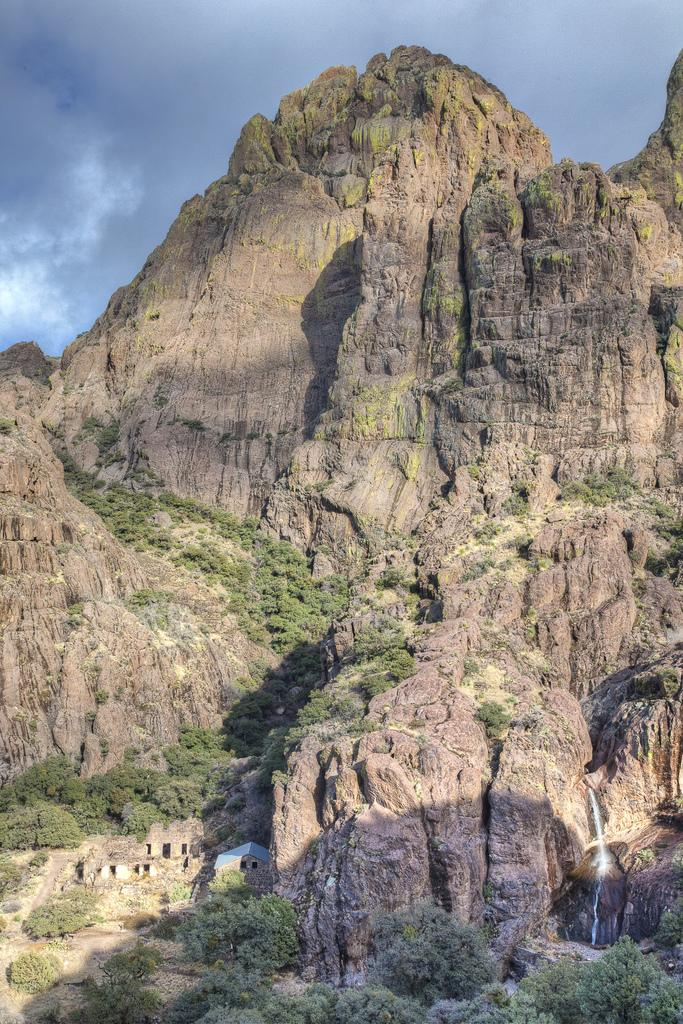What type of structures can be seen in the image? There are buildings in the image. What natural features are present in the image? There are mountains and trees in the image. What part of the natural environment is visible in the image? The sky is visible in the image. What type of advertisement can be seen on the mountains in the image? There are no advertisements present on the mountains in the image; they are natural features. 